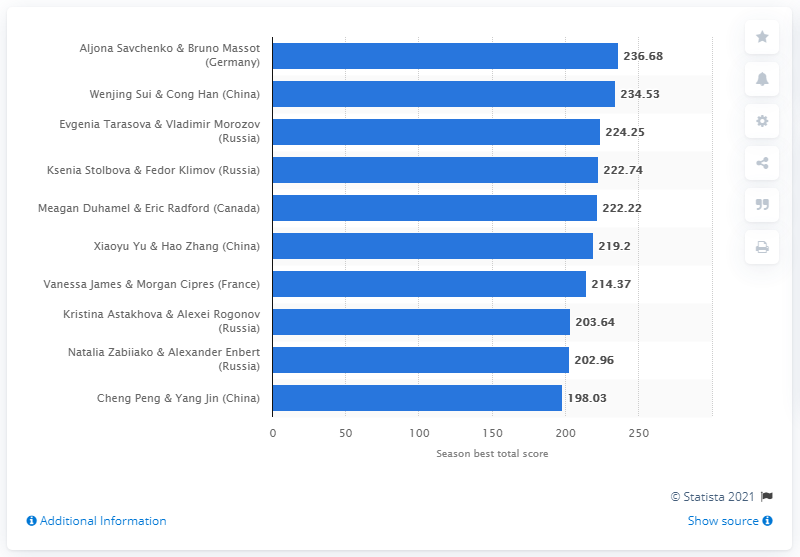Indicate a few pertinent items in this graphic. Aljona Savchenko and Bruno Massot achieved the top score of 236.68 in their figure skating performance. 